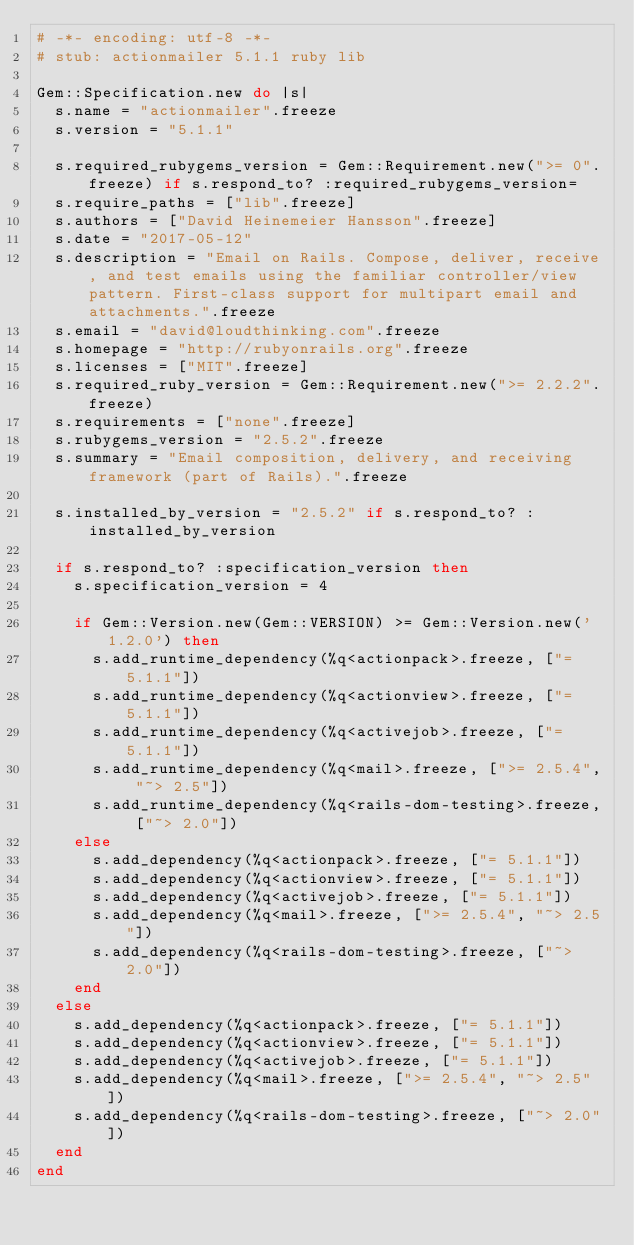<code> <loc_0><loc_0><loc_500><loc_500><_Ruby_># -*- encoding: utf-8 -*-
# stub: actionmailer 5.1.1 ruby lib

Gem::Specification.new do |s|
  s.name = "actionmailer".freeze
  s.version = "5.1.1"

  s.required_rubygems_version = Gem::Requirement.new(">= 0".freeze) if s.respond_to? :required_rubygems_version=
  s.require_paths = ["lib".freeze]
  s.authors = ["David Heinemeier Hansson".freeze]
  s.date = "2017-05-12"
  s.description = "Email on Rails. Compose, deliver, receive, and test emails using the familiar controller/view pattern. First-class support for multipart email and attachments.".freeze
  s.email = "david@loudthinking.com".freeze
  s.homepage = "http://rubyonrails.org".freeze
  s.licenses = ["MIT".freeze]
  s.required_ruby_version = Gem::Requirement.new(">= 2.2.2".freeze)
  s.requirements = ["none".freeze]
  s.rubygems_version = "2.5.2".freeze
  s.summary = "Email composition, delivery, and receiving framework (part of Rails).".freeze

  s.installed_by_version = "2.5.2" if s.respond_to? :installed_by_version

  if s.respond_to? :specification_version then
    s.specification_version = 4

    if Gem::Version.new(Gem::VERSION) >= Gem::Version.new('1.2.0') then
      s.add_runtime_dependency(%q<actionpack>.freeze, ["= 5.1.1"])
      s.add_runtime_dependency(%q<actionview>.freeze, ["= 5.1.1"])
      s.add_runtime_dependency(%q<activejob>.freeze, ["= 5.1.1"])
      s.add_runtime_dependency(%q<mail>.freeze, [">= 2.5.4", "~> 2.5"])
      s.add_runtime_dependency(%q<rails-dom-testing>.freeze, ["~> 2.0"])
    else
      s.add_dependency(%q<actionpack>.freeze, ["= 5.1.1"])
      s.add_dependency(%q<actionview>.freeze, ["= 5.1.1"])
      s.add_dependency(%q<activejob>.freeze, ["= 5.1.1"])
      s.add_dependency(%q<mail>.freeze, [">= 2.5.4", "~> 2.5"])
      s.add_dependency(%q<rails-dom-testing>.freeze, ["~> 2.0"])
    end
  else
    s.add_dependency(%q<actionpack>.freeze, ["= 5.1.1"])
    s.add_dependency(%q<actionview>.freeze, ["= 5.1.1"])
    s.add_dependency(%q<activejob>.freeze, ["= 5.1.1"])
    s.add_dependency(%q<mail>.freeze, [">= 2.5.4", "~> 2.5"])
    s.add_dependency(%q<rails-dom-testing>.freeze, ["~> 2.0"])
  end
end
</code> 